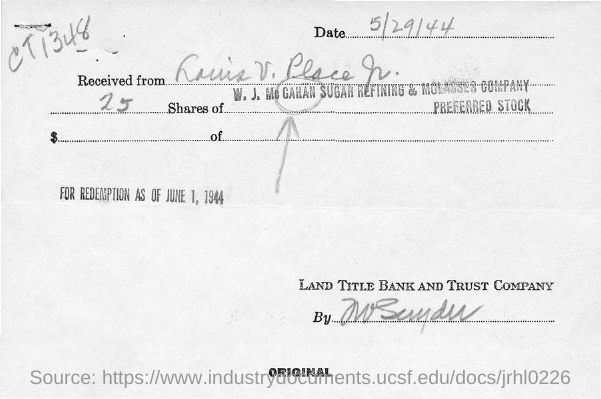What is the date mentioned on the top right corner?
Your response must be concise. 5/29/44. What is the number of shares?
Offer a very short reply. 25. What is the company name mentioned at the bottom right corner?
Keep it short and to the point. Land title bank and trust company. Shares are of which company?
Offer a terse response. W. J. Mc Gahan sugar refining & molasses company. What is the code handwritten on the top right corner?
Your answer should be compact. CT1348. What is the date for redemption?
Provide a succinct answer. June 1, 1944. 